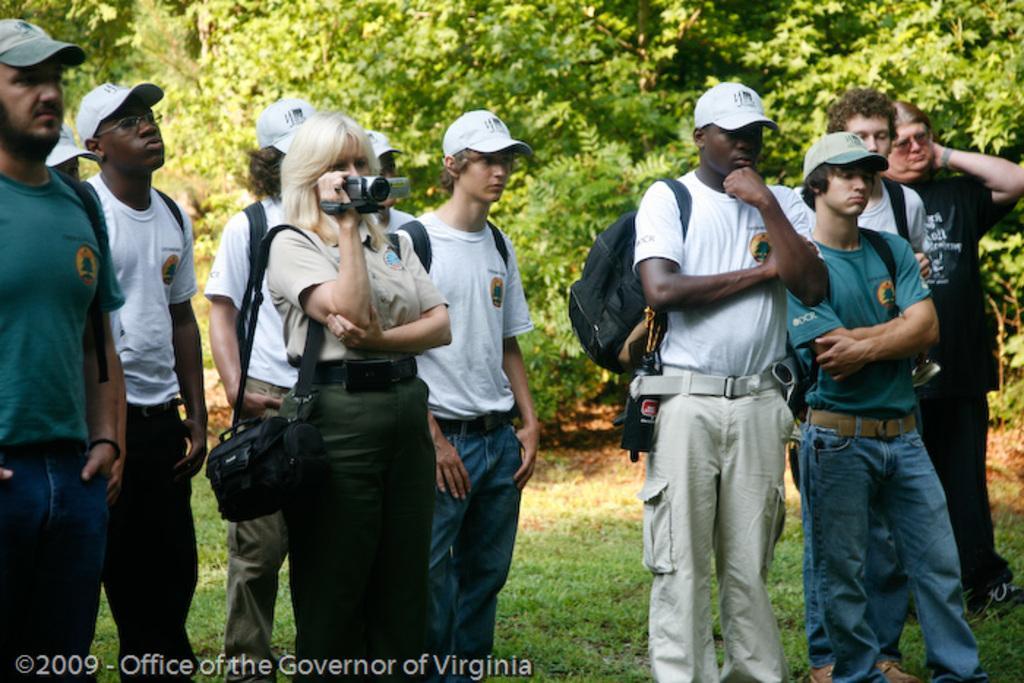Can you describe this image briefly? In this image there are a group of people standing and some of them are wearing caps, and one woman is holding a camera and wearing a bag. At the bottom there is grass and at the bottom of the image there is text and in the background there are some trees. 